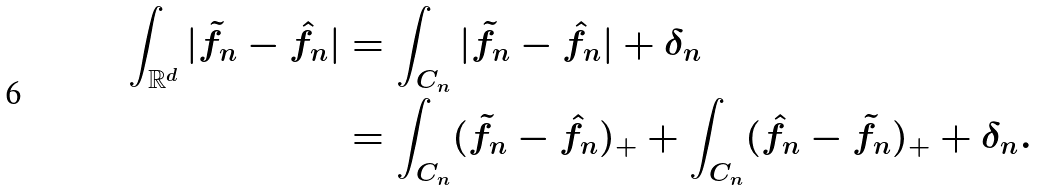<formula> <loc_0><loc_0><loc_500><loc_500>\int _ { \mathbb { R } ^ { d } } | \tilde { f } _ { n } - \hat { f } _ { n } | & = \int _ { C _ { n } } | \tilde { f } _ { n } - \hat { f } _ { n } | + \delta _ { n } \\ & = \int _ { C _ { n } } ( \tilde { f } _ { n } - \hat { f } _ { n } ) _ { + } + \int _ { C _ { n } } ( \hat { f } _ { n } - \tilde { f } _ { n } ) _ { + } + \delta _ { n } .</formula> 